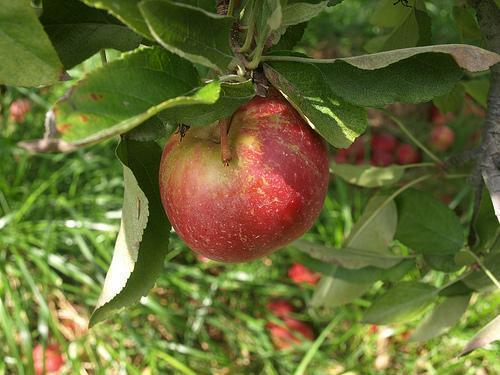How many apples are in focus?
Give a very brief answer. 1. 